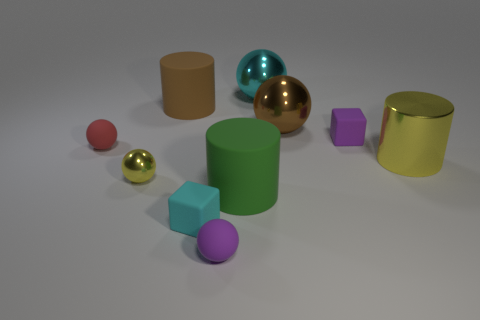Subtract 2 balls. How many balls are left? 3 Subtract all matte cylinders. How many cylinders are left? 1 Subtract all brown balls. How many balls are left? 4 Subtract all blue balls. Subtract all brown cubes. How many balls are left? 5 Subtract all cylinders. How many objects are left? 7 Subtract all yellow metal cylinders. Subtract all purple spheres. How many objects are left? 8 Add 7 tiny yellow shiny things. How many tiny yellow shiny things are left? 8 Add 5 small rubber balls. How many small rubber balls exist? 7 Subtract 1 purple spheres. How many objects are left? 9 